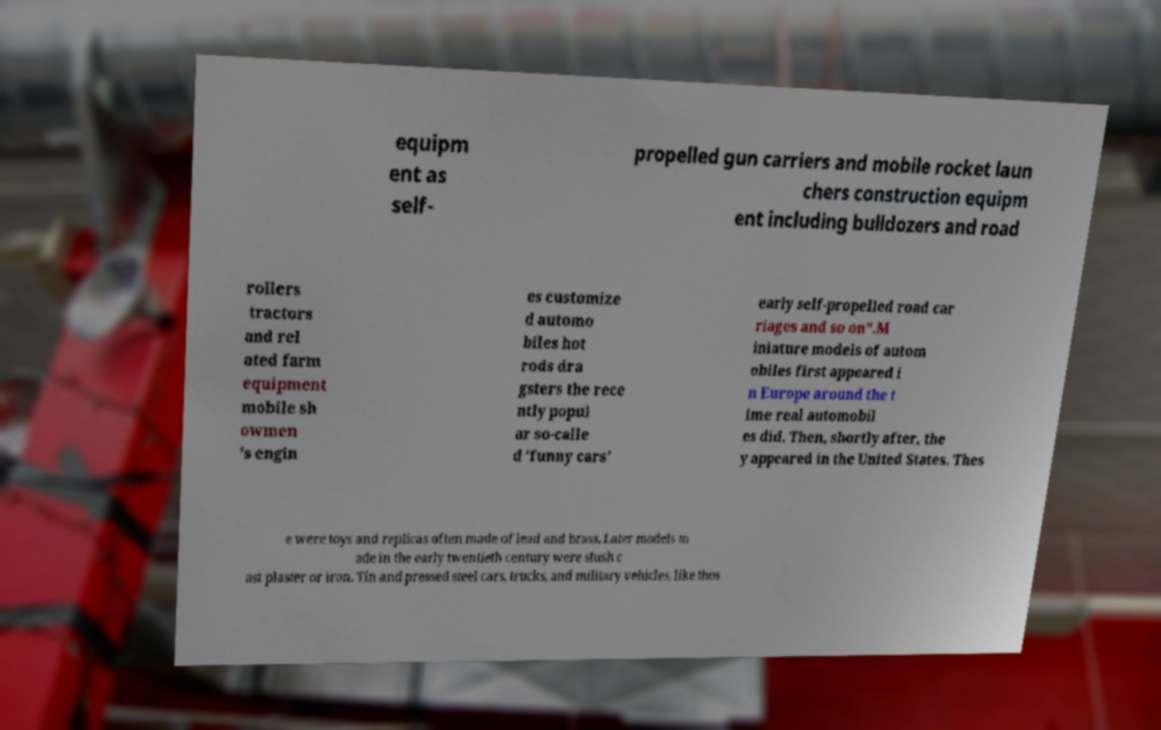Could you assist in decoding the text presented in this image and type it out clearly? equipm ent as self- propelled gun carriers and mobile rocket laun chers construction equipm ent including bulldozers and road rollers tractors and rel ated farm equipment mobile sh owmen 's engin es customize d automo biles hot rods dra gsters the rece ntly popul ar so-calle d 'funny cars' early self-propelled road car riages and so on".M iniature models of autom obiles first appeared i n Europe around the t ime real automobil es did. Then, shortly after, the y appeared in the United States. Thes e were toys and replicas often made of lead and brass. Later models m ade in the early twentieth century were slush c ast plaster or iron. Tin and pressed steel cars, trucks, and military vehicles, like thos 